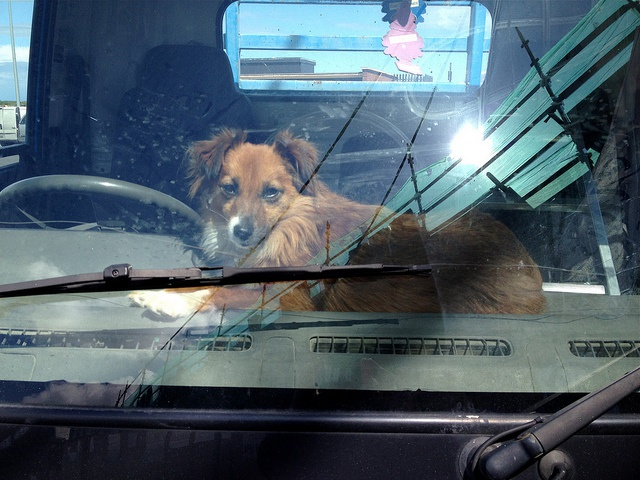Describe the objects in this image and their specific colors. I can see car in black, gray, navy, and darkgray tones and dog in lightblue, black, gray, darkgray, and tan tones in this image. 